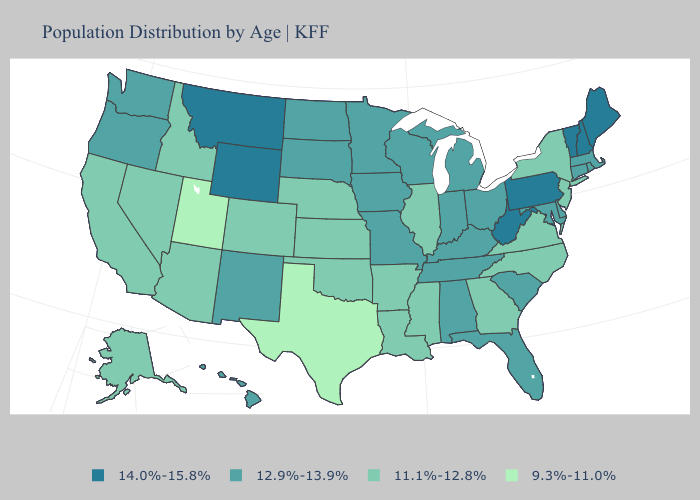Does the map have missing data?
Concise answer only. No. Name the states that have a value in the range 14.0%-15.8%?
Concise answer only. Maine, Montana, New Hampshire, Pennsylvania, Vermont, West Virginia, Wyoming. Does Oregon have the highest value in the West?
Short answer required. No. Does the first symbol in the legend represent the smallest category?
Be succinct. No. What is the value of South Carolina?
Short answer required. 12.9%-13.9%. Name the states that have a value in the range 12.9%-13.9%?
Keep it brief. Alabama, Connecticut, Delaware, Florida, Hawaii, Indiana, Iowa, Kentucky, Maryland, Massachusetts, Michigan, Minnesota, Missouri, New Mexico, North Dakota, Ohio, Oregon, Rhode Island, South Carolina, South Dakota, Tennessee, Washington, Wisconsin. What is the lowest value in states that border Minnesota?
Give a very brief answer. 12.9%-13.9%. Does New Jersey have the lowest value in the Northeast?
Short answer required. Yes. What is the value of Louisiana?
Keep it brief. 11.1%-12.8%. Which states have the lowest value in the West?
Quick response, please. Utah. What is the lowest value in states that border Iowa?
Quick response, please. 11.1%-12.8%. Among the states that border New Hampshire , does Vermont have the lowest value?
Keep it brief. No. Name the states that have a value in the range 11.1%-12.8%?
Answer briefly. Alaska, Arizona, Arkansas, California, Colorado, Georgia, Idaho, Illinois, Kansas, Louisiana, Mississippi, Nebraska, Nevada, New Jersey, New York, North Carolina, Oklahoma, Virginia. Does Pennsylvania have the same value as North Carolina?
Write a very short answer. No. 